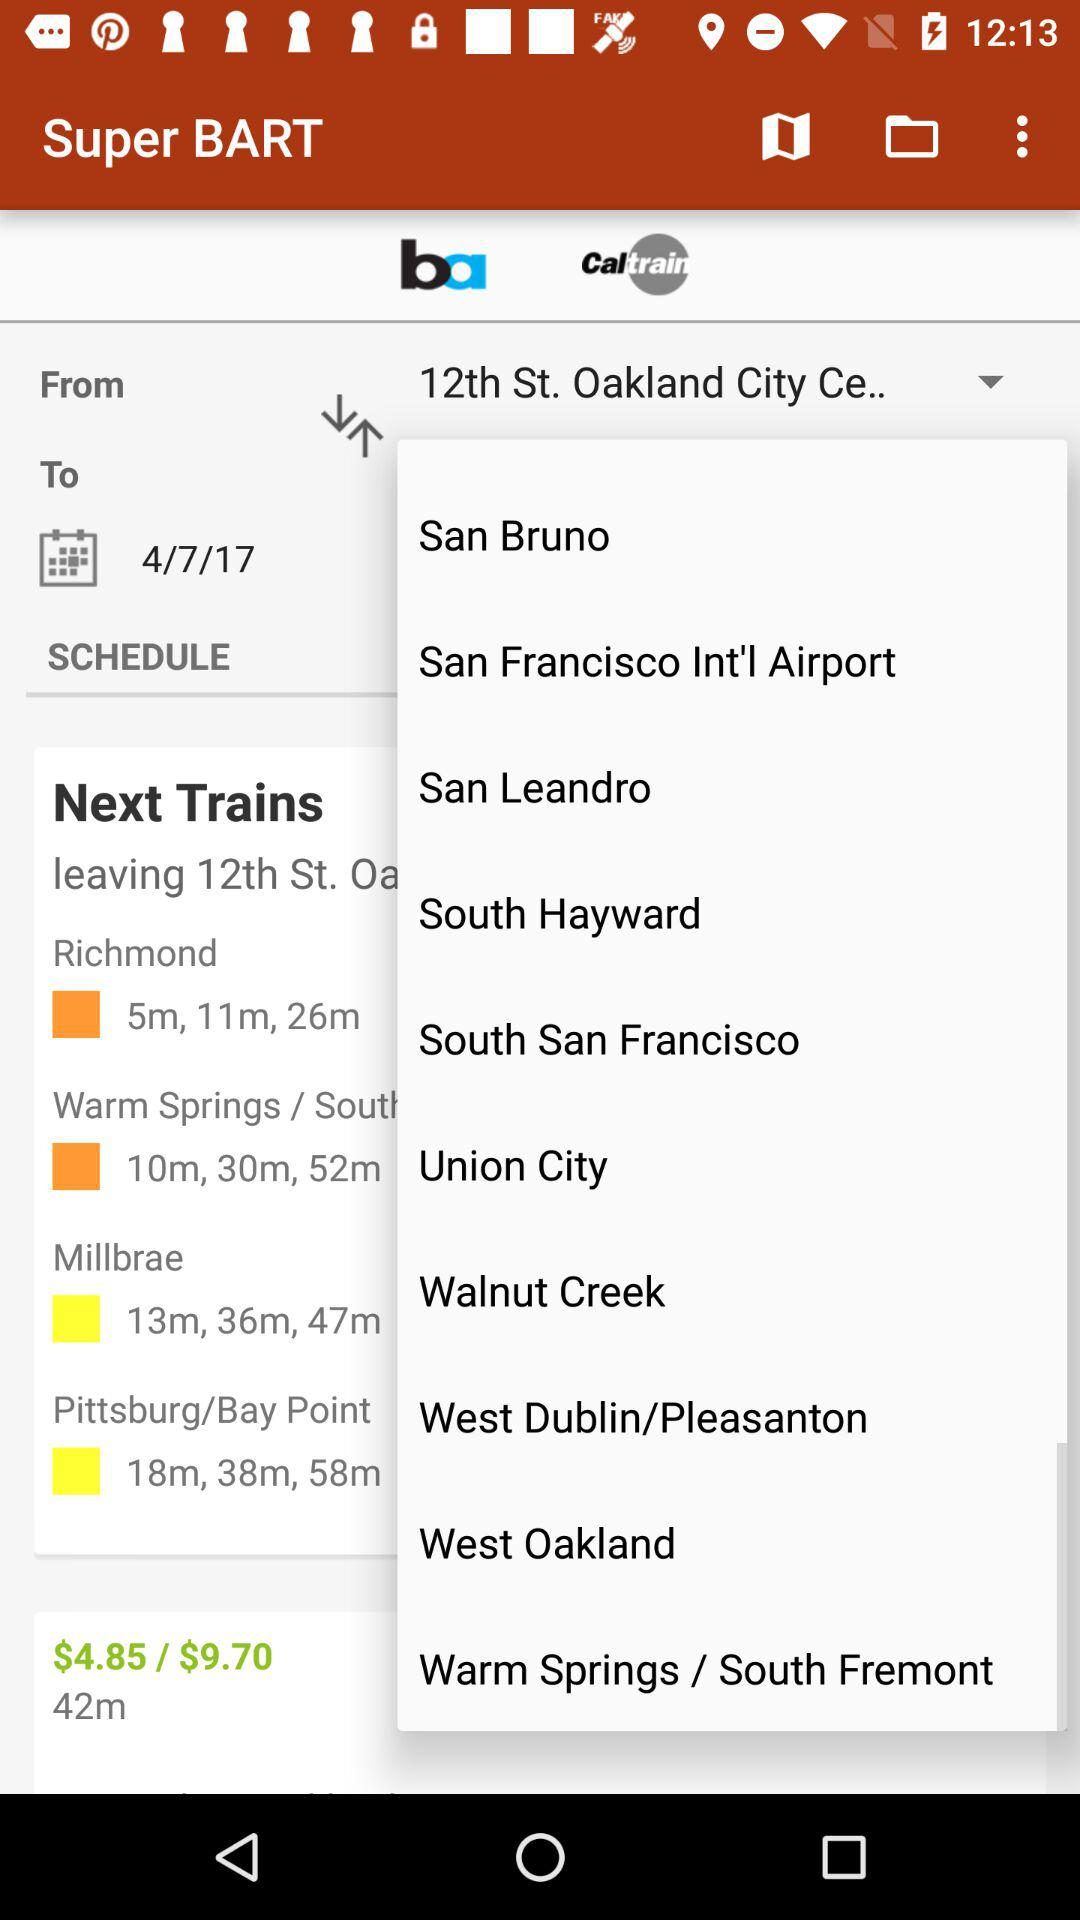Which is the start location? The start location is "12th ST. Oakland City Ce..". 